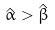<formula> <loc_0><loc_0><loc_500><loc_500>\hat { \alpha } > \hat { \beta }</formula> 